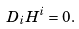<formula> <loc_0><loc_0><loc_500><loc_500>D _ { i } H ^ { i } = 0 .</formula> 